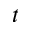Convert formula to latex. <formula><loc_0><loc_0><loc_500><loc_500>t</formula> 